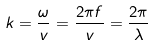<formula> <loc_0><loc_0><loc_500><loc_500>k = { \frac { \omega } { v } } = { \frac { 2 \pi f } { v } } = { \frac { 2 \pi } { \lambda } }</formula> 